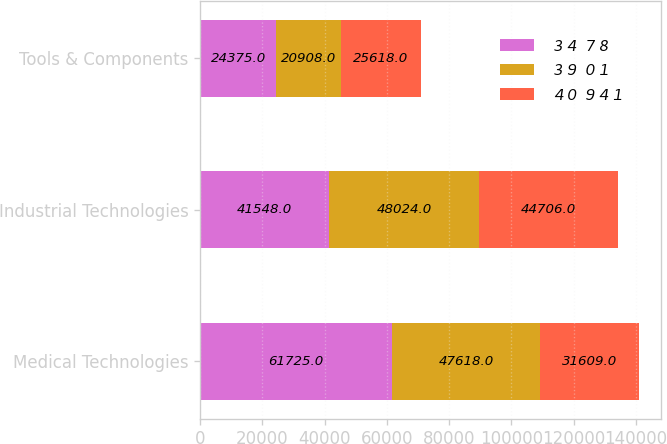<chart> <loc_0><loc_0><loc_500><loc_500><stacked_bar_chart><ecel><fcel>Medical Technologies<fcel>Industrial Technologies<fcel>Tools & Components<nl><fcel>3 4  7 8<fcel>61725<fcel>41548<fcel>24375<nl><fcel>3 9  0 1<fcel>47618<fcel>48024<fcel>20908<nl><fcel>4 0  9 4 1<fcel>31609<fcel>44706<fcel>25618<nl></chart> 